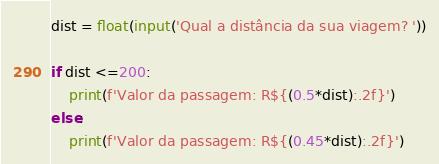<code> <loc_0><loc_0><loc_500><loc_500><_Python_>dist = float(input('Qual a distância da sua viagem? '))

if dist <=200:
    print(f'Valor da passagem: R${(0.5*dist):.2f}')
else:
    print(f'Valor da passagem: R${(0.45*dist):.2f}')</code> 